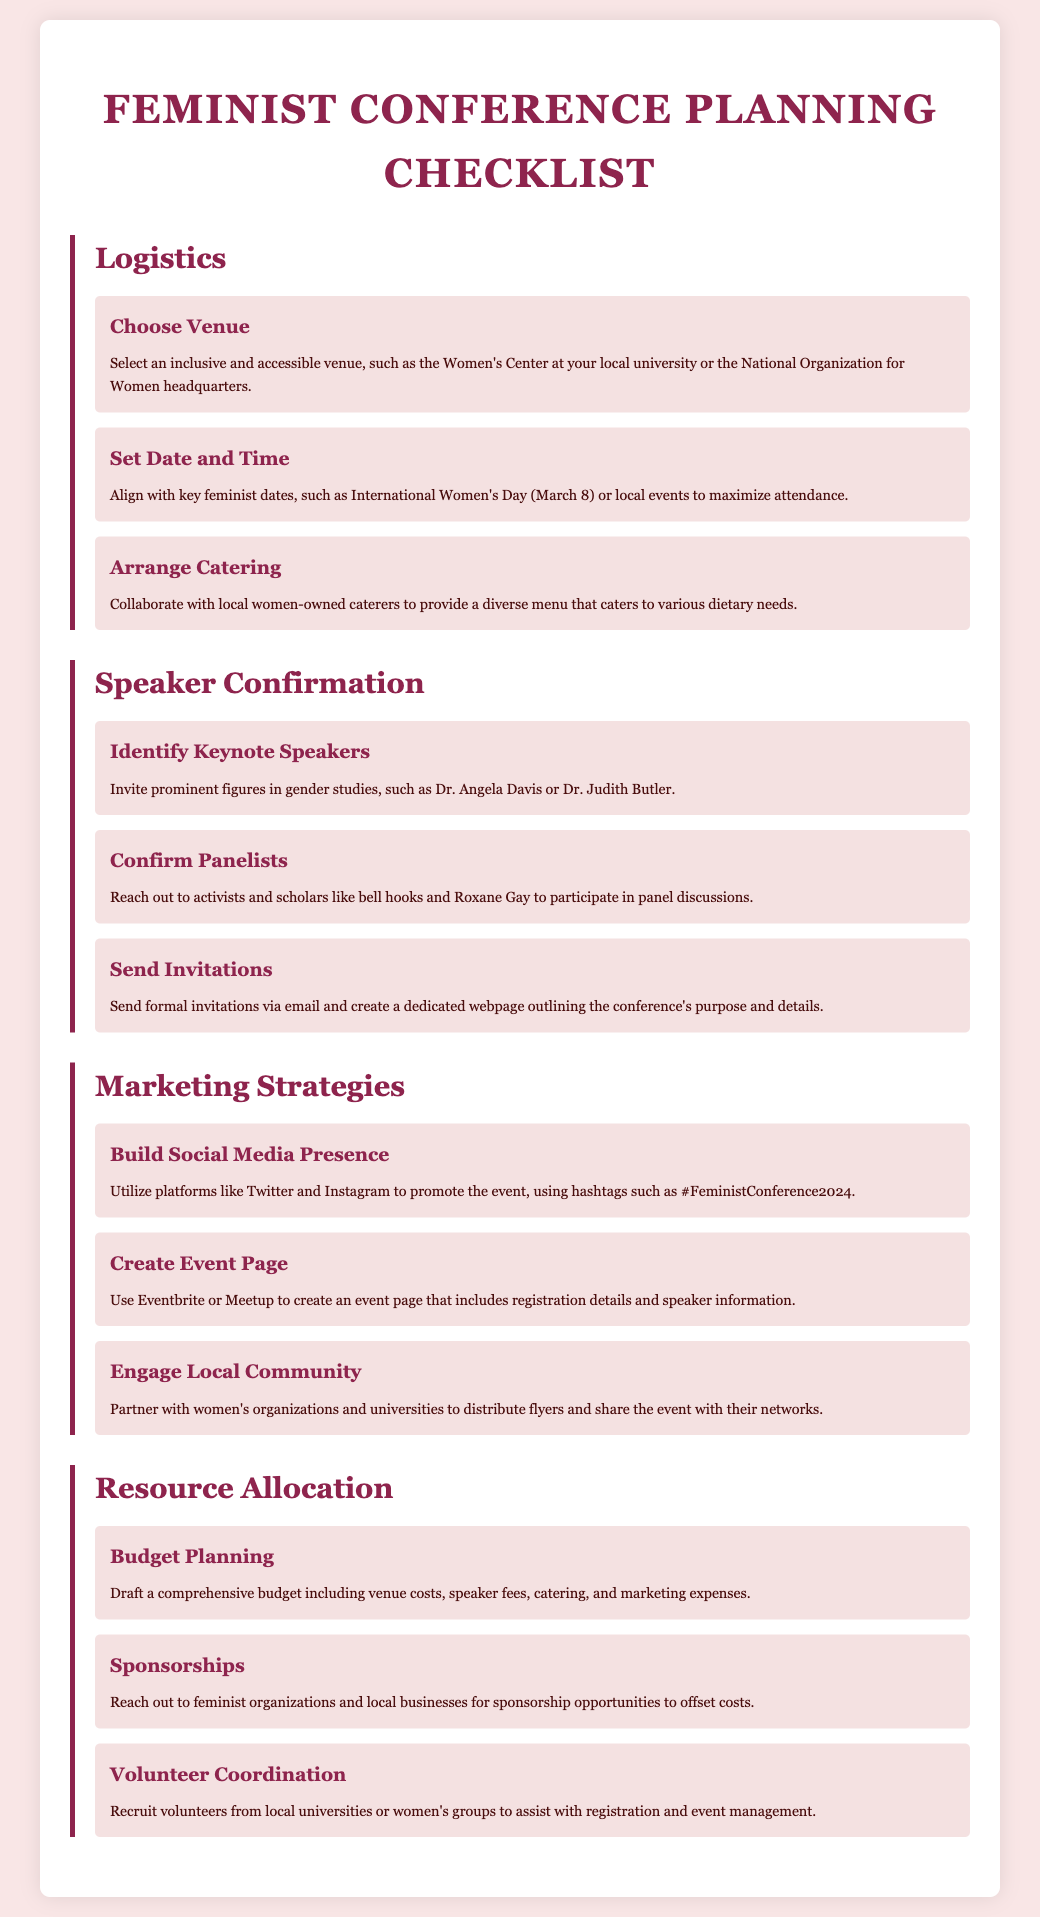what is the title of the document? The title of the document is presented at the top of the rendered page.
Answer: Feminist Conference Planning Checklist who is a suggested keynote speaker? The document lists prominent figures in gender studies as keynote speakers.
Answer: Dr. Angela Davis which social media platforms are recommended for marketing? The document mentions specific platforms for promoting the event.
Answer: Twitter and Instagram what is a suggested catering option? The document provides options for catering that align with feminist values.
Answer: Women-owned caterers how can sponsorships be obtained? The document outlines a method for funding event costs through community support.
Answer: Reach out to feminist organizations which date is suggested for the conference? The document advises aligning the date with important feminist dates.
Answer: International Women's Day who is suggested for volunteer coordination? The document specifies a source for recruiting volunteers to manage the event.
Answer: Local universities or women's groups what is included in the budget planning? The document lists components necessary for a comprehensive budget.
Answer: Venue costs, speaker fees, catering, and marketing expenses how can the local community be engaged? The document provides strategies for connecting with the local community.
Answer: Partner with women's organizations and universities 